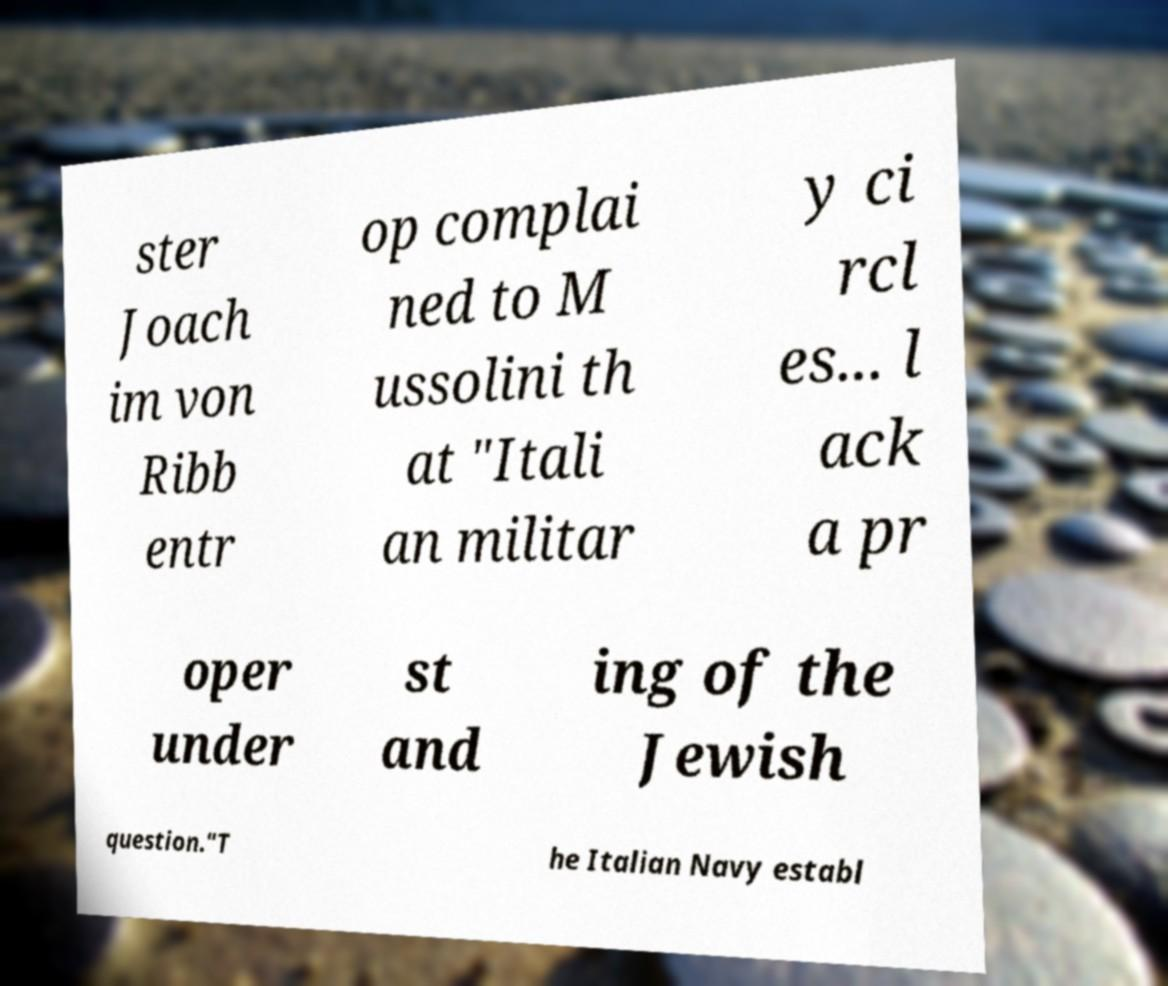What messages or text are displayed in this image? I need them in a readable, typed format. ster Joach im von Ribb entr op complai ned to M ussolini th at "Itali an militar y ci rcl es... l ack a pr oper under st and ing of the Jewish question."T he Italian Navy establ 